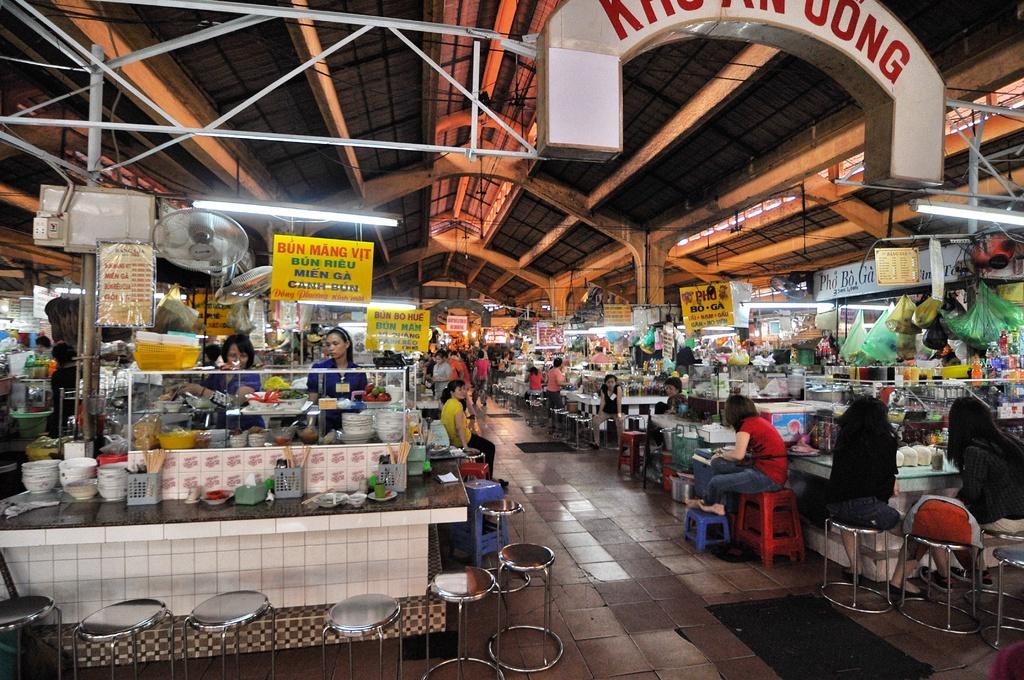What is being sold at the stall on the left?
Your answer should be compact. Unanswerable. 